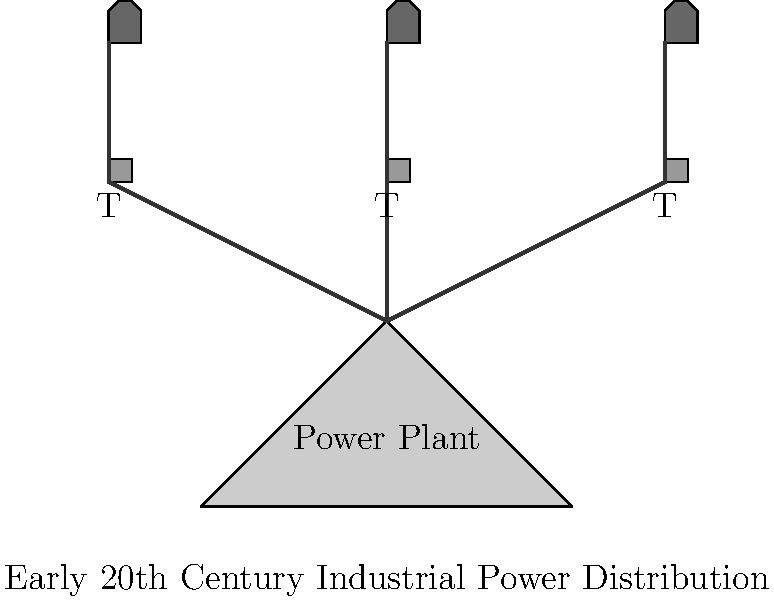In the schematic diagram of early 20th century industrial power distribution, what role did the intermediate structures labeled "T" likely play, and how might this arrangement have influenced the social and economic dynamics of industrial areas? To answer this question, we need to analyze the diagram and consider the historical context of early 20th century industrialization:

1. The diagram shows a power plant connected to multiple structures labeled "T," which in turn connect to factory-like buildings.

2. Given the context of electrical power distribution, the "T" structures most likely represent transformer stations. These were crucial components in early electrical systems for several reasons:

   a) They allowed for the stepping down of high voltage from power plants to more manageable levels for industrial use.
   b) They enabled power to be distributed over longer distances with minimal loss.

3. The arrangement of having multiple transformer stations suggests a decentralized power distribution system, which had several implications:

   a) It allowed for more efficient power distribution to multiple factories or industrial zones.
   b) It provided flexibility in the growth and development of industrial areas.

4. From a social and economic perspective, this arrangement likely influenced industrial areas in the following ways:

   a) It facilitated the growth of industrial clusters, as reliable power could be distributed to multiple factories in proximity.
   b) This clustering effect could lead to the formation of industrial towns or districts, changing the urban landscape.
   c) The availability of distributed power could attract more businesses to an area, potentially leading to economic growth and job creation.
   d) The presence of these transformer stations and power lines would have been a visible sign of modernization and progress, potentially influencing public perception and community dynamics.

5. Additionally, this system would have required specialized workers for maintenance and operation, potentially creating new job categories and social classes within industrial communities.

In conclusion, the "T" structures likely represent transformer stations, which played a crucial role in enabling the efficient distribution of electrical power to multiple industrial sites. This arrangement would have facilitated the growth of industrial clusters, potentially reshaping the social and economic landscape of early 20th century industrial areas.
Answer: Transformer stations; facilitated industrial clustering and urban development 